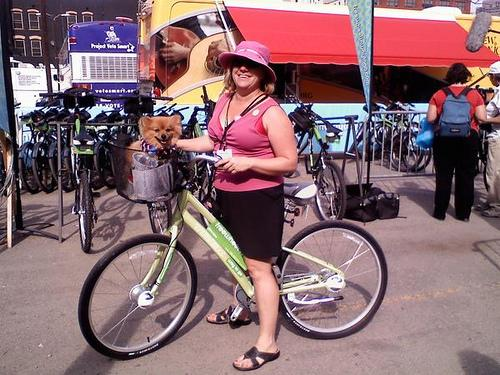Which wrong accessory has the woman worn for riding bike? sandals 